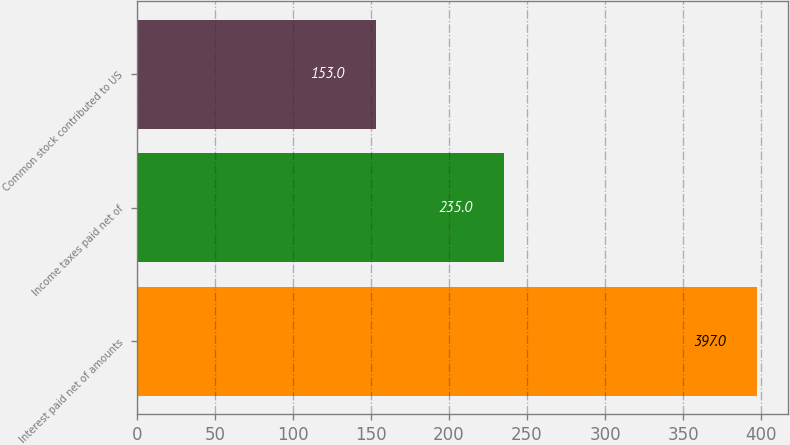Convert chart to OTSL. <chart><loc_0><loc_0><loc_500><loc_500><bar_chart><fcel>Interest paid net of amounts<fcel>Income taxes paid net of<fcel>Common stock contributed to US<nl><fcel>397<fcel>235<fcel>153<nl></chart> 